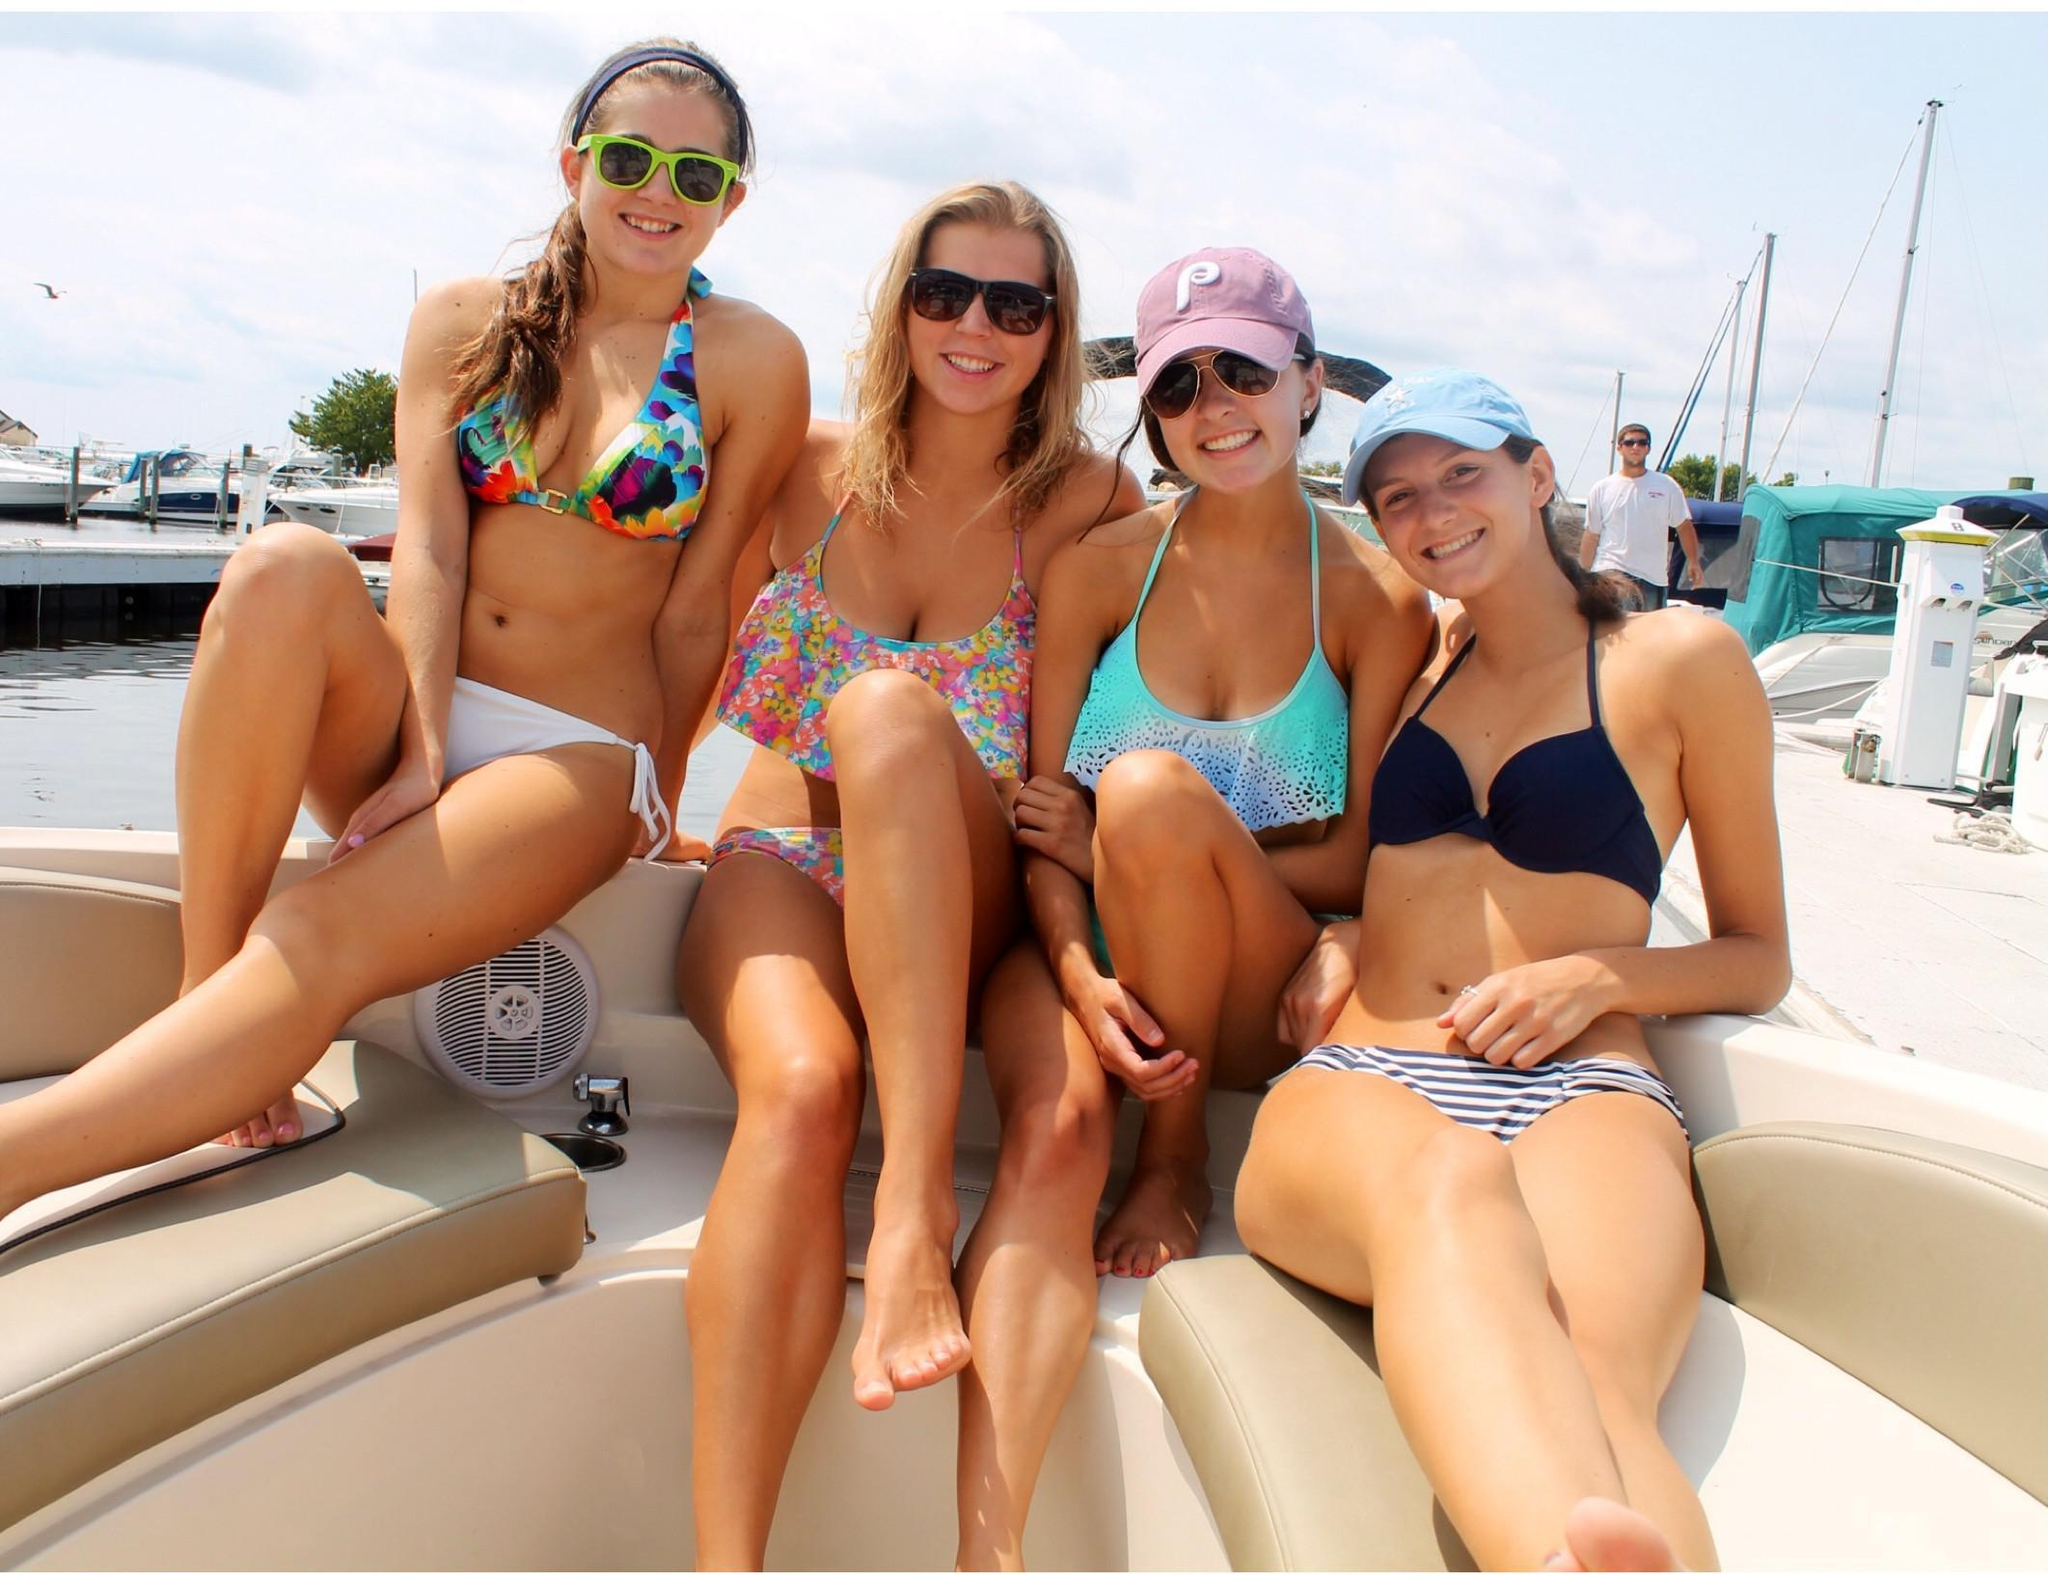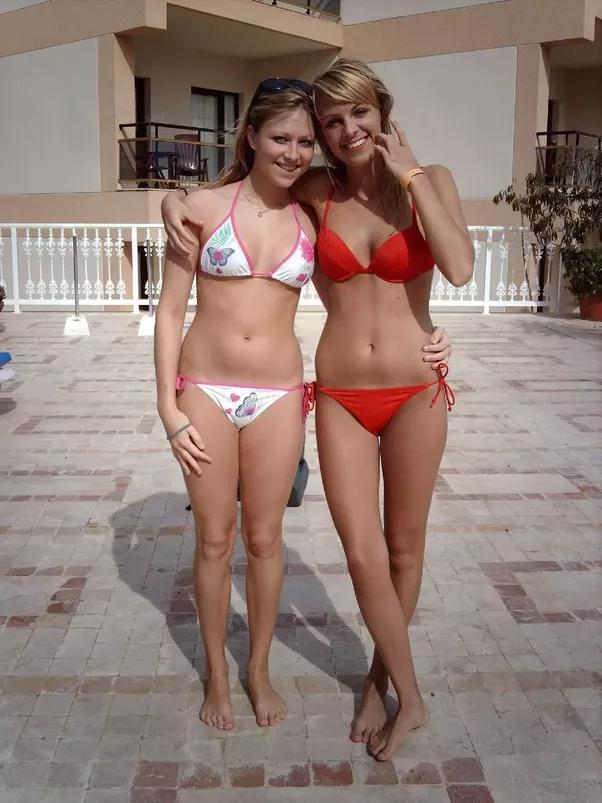The first image is the image on the left, the second image is the image on the right. For the images shown, is this caption "The combined images show four females in bikinis on the beach, and three bikini tops are the same solid color." true? Answer yes or no. No. The first image is the image on the left, the second image is the image on the right. For the images displayed, is the sentence "One image shows two women side by side modelling bikinis with similar colors." factually correct? Answer yes or no. No. 